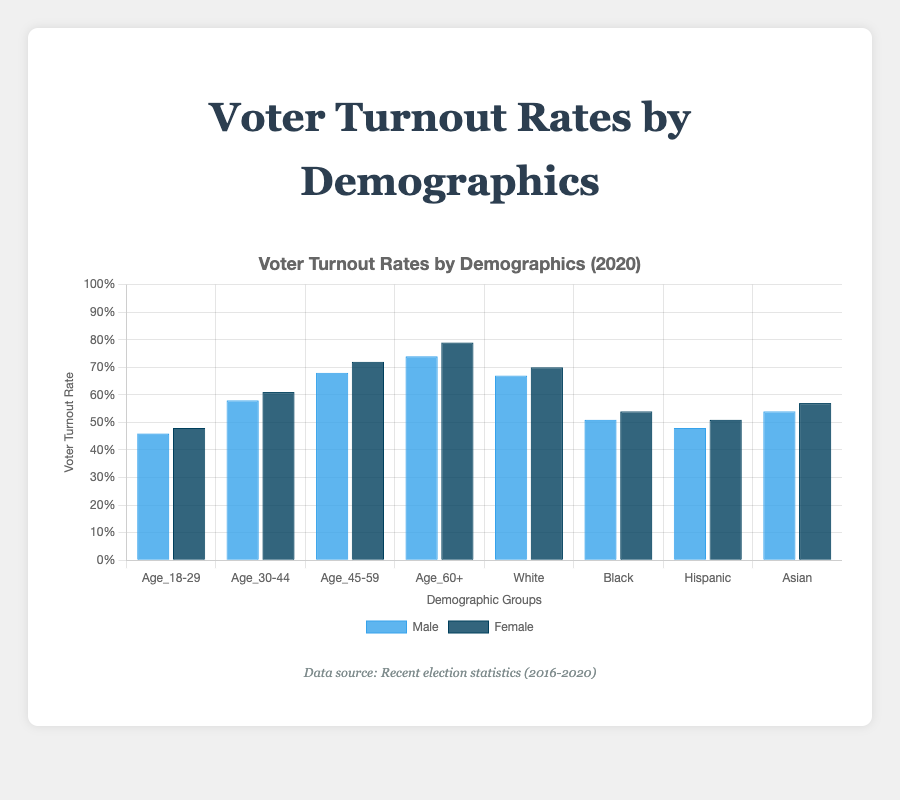Which age group had the highest voter turnout among females in 2020? By inspecting the height of the dark blue bars (representing females) across all age groups in 2020, the Age_60+ group has the highest bar, indicating the highest turnout.
Answer: Age_60+ Compare the voter turnout rates for Black males and Black females in 2020. Which gender had a higher turnout? Observe the blue and dark blue bars for the Black demographic in 2020. The dark blue bar (female) is taller than the blue bar (male), indicating a higher turnout.
Answer: Female What is the difference in voter turnout rates between Hispanic females and Hispanic males in 2016? Examine the bars for the Hispanic demographic in 2016. The heights of the bars are 0.47 for females and 0.44 for males. The difference is 0.47 - 0.44.
Answer: 0.03 Which gender had a higher voter turnout rate in the Age_30-44 group in 2018? Compare the male and female bars for the Age_30-44 demographic in 2018. The dark blue bar (female) is taller than the blue bar (male), indicating a higher turnout for females.
Answer: Female What was the average voter turnout rate for White females over the three elections? The voter turnout rates for White females are 0.70 (2020), 0.62 (2018), and 0.68 (2016). Compute the average: (0.70 + 0.62 + 0.68) / 3 = 2 / 3 = 0.66667.
Answer: 0.67 How much did the voter turnout rate for Black males increase from 2018 to 2020? Compare the bars for Black males in 2018 and 2020. The turnout rates are 0.41 (2018) and 0.51 (2020). The increase is 0.51 - 0.41.
Answer: 0.10 In 2020, which gender had a higher turnout rate among Asian voters? Compare the male and female bars for the Asian demographic in 2020. The dark blue bar (female) is slightly taller than the blue bar (male), indicating a higher turnout for females.
Answer: Female What is the combined voter turnout rate for White males and White females in 2020? To find the combined turnout rate, add the turnout rates for White males and females in 2020: 0.67 (male) + 0.70 (female).
Answer: 1.37 Compare the trend in voter turnout rates for the Age_18-29 group from 2016 to 2020. Did any gender consistently show higher turnout? Examine the heights of the bars for Age_18-29 from 2016 to 2020. For each year, the dark blue bar (female) is slightly taller than the blue bar (male), indicating that females consistently had higher turnout.
Answer: Female What was the increase in voter turnout rate for Hispanic females from 2016 to 2020? Compare the bars for Hispanic females in 2016 and 2020. The turnout rates are 0.47 (2016) and 0.51 (2020). The increase is 0.51 - 0.47.
Answer: 0.04 